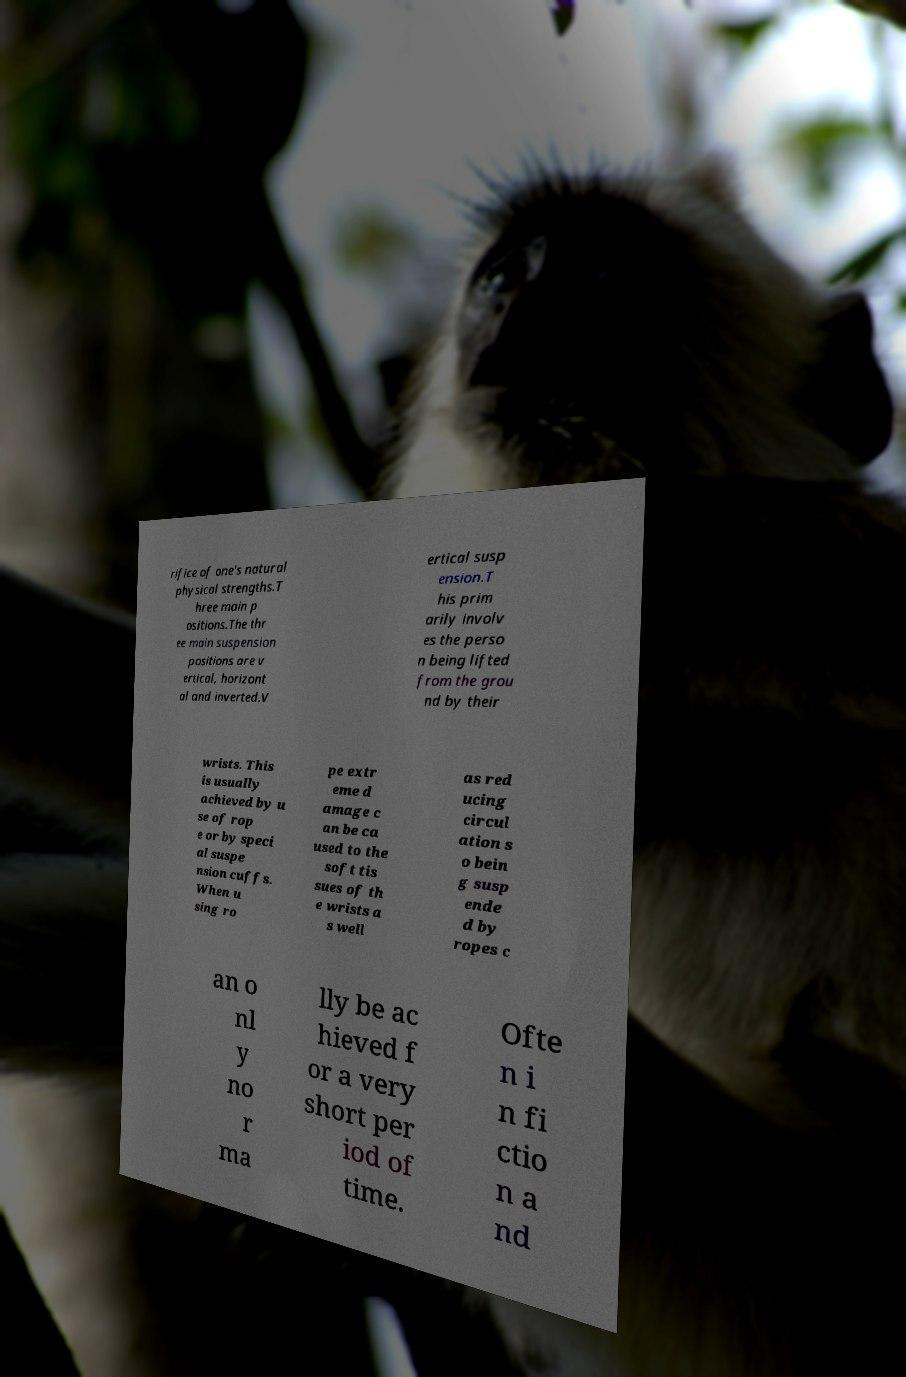Can you read and provide the text displayed in the image?This photo seems to have some interesting text. Can you extract and type it out for me? rifice of one's natural physical strengths.T hree main p ositions.The thr ee main suspension positions are v ertical, horizont al and inverted.V ertical susp ension.T his prim arily involv es the perso n being lifted from the grou nd by their wrists. This is usually achieved by u se of rop e or by speci al suspe nsion cuffs. When u sing ro pe extr eme d amage c an be ca used to the soft tis sues of th e wrists a s well as red ucing circul ation s o bein g susp ende d by ropes c an o nl y no r ma lly be ac hieved f or a very short per iod of time. Ofte n i n fi ctio n a nd 